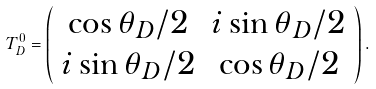Convert formula to latex. <formula><loc_0><loc_0><loc_500><loc_500>T _ { D } ^ { 0 } = \left ( \begin{array} { c c } \cos \theta _ { D } / 2 & i \sin \theta _ { D } / 2 \\ i \sin \theta _ { D } / 2 & \cos \theta _ { D } / 2 \end{array} \right ) .</formula> 